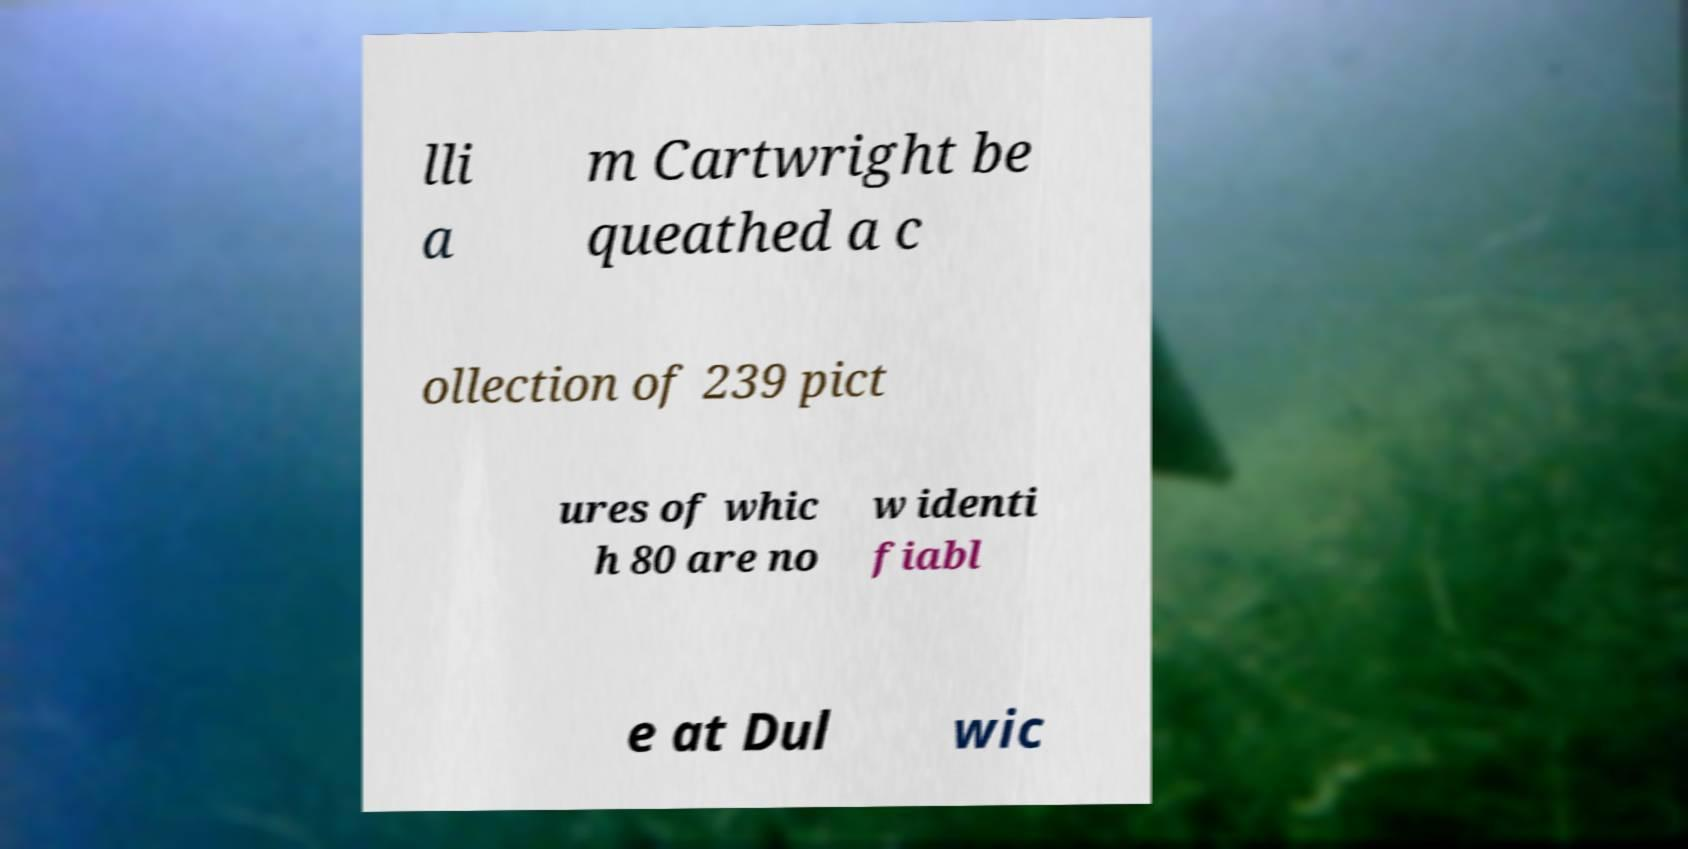Can you accurately transcribe the text from the provided image for me? lli a m Cartwright be queathed a c ollection of 239 pict ures of whic h 80 are no w identi fiabl e at Dul wic 